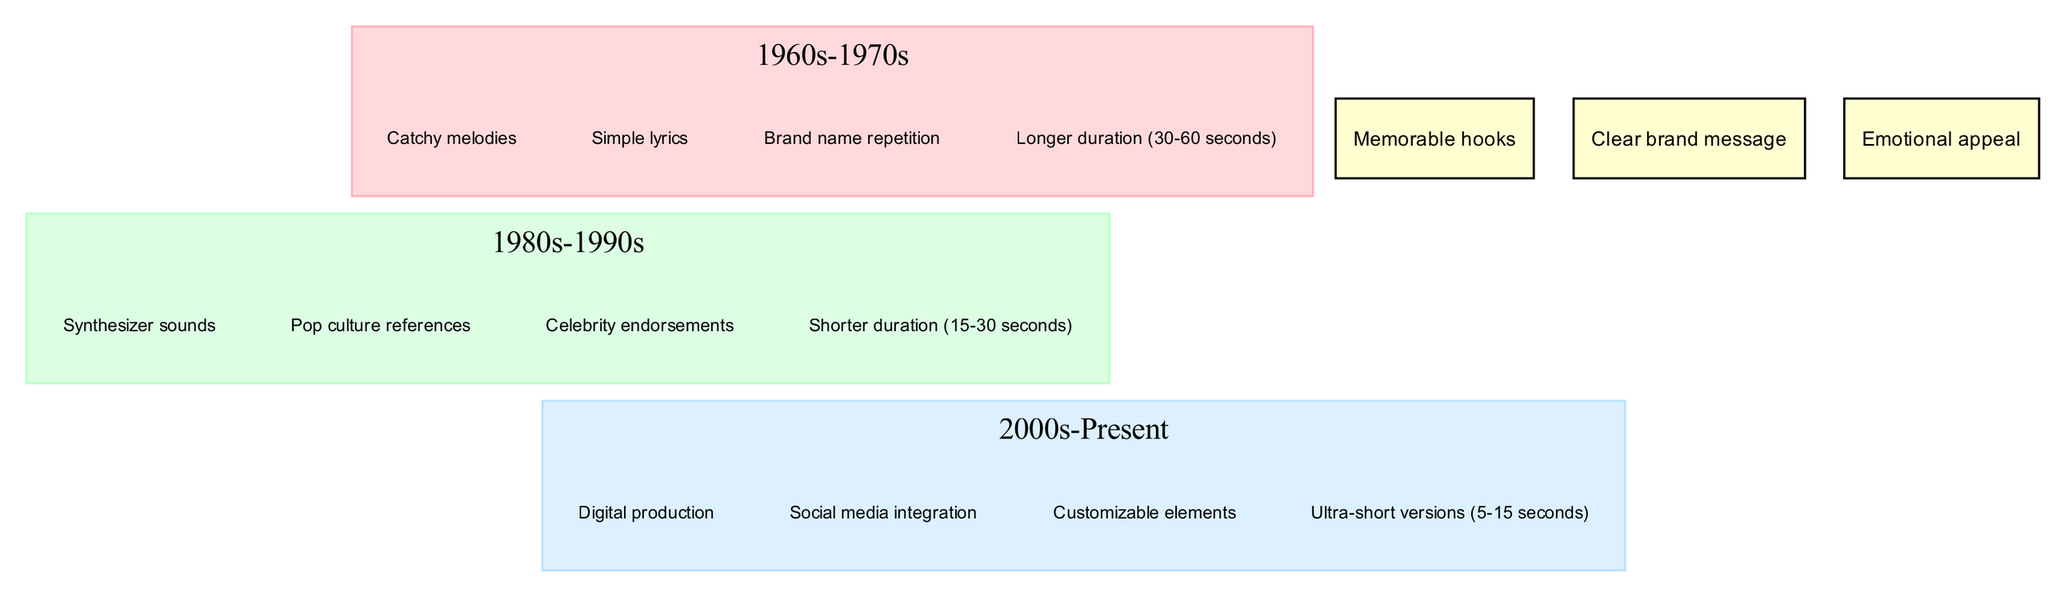What characteristics are unique to the 1960s-1970s jingle? The characteristics listed under the 1960s-1970s circle are "Catchy melodies," "Simple lyrics," "Brand name repetition," and "Longer duration (30-60 seconds)." Since no other circle shares these specific traits, they are unique to that decade.
Answer: Catchy melodies, Simple lyrics, Brand name repetition, Longer duration (30-60 seconds) How many characteristics are shared across all decades? The intersection labeled "All Decades" lists three shared characteristics: "Memorable hooks," "Clear brand message," and "Emotional appeal." Therefore, the count of shared characteristics can be derived from this intersection.
Answer: 3 What is the duration range for jingles in the 1980s-1990s? By checking the characteristics under the 1980s-1990s circle, we find "Shorter duration (15-30 seconds)." This provides the specific information needed to answer the question.
Answer: Shorter duration (15-30 seconds) Which decade introduces digital production as a characteristic? The "Digital production" characteristic is listed under the 2000s-Present circle. Analyzing each circle shows that this trait does not appear in any earlier decades, marking it as exclusive to the more modern period.
Answer: 2000s-Present Is "Clear brand message" present in the 1960s-1970s characteristics? Checking the characteristics listed under the 1960s-1970s circle reveals that "Clear brand message" is not included. However, it does appear in the "All Decades" intersection, indicating it's a common trait but not specific to that particular decade.
Answer: No 